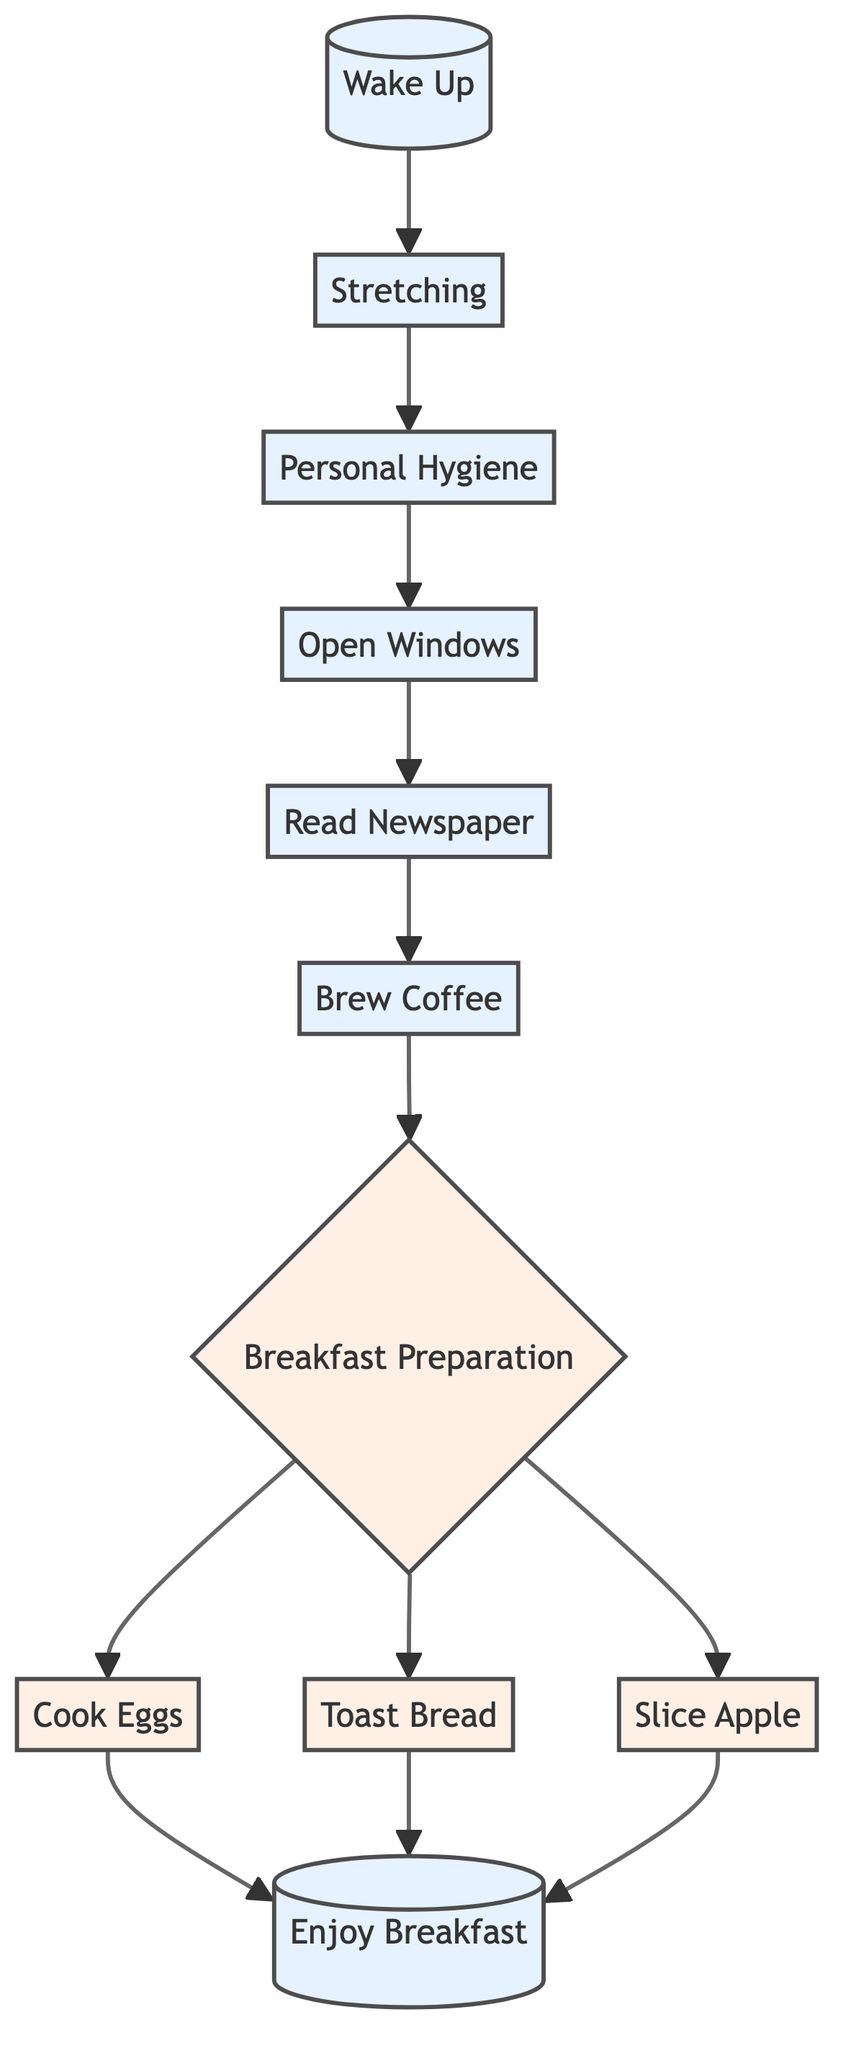What is the first step in the morning routine? The first step listed in the diagram is "Wake Up".
Answer: Wake Up How many tasks are involved in breakfast preparation? The breakfast preparation section has three tasks listed: Cook Eggs, Toast Bread, and Slice Apple. Therefore, the total number of tasks is three.
Answer: 3 What activity comes right after personal hygiene? The diagram shows that after "Personal Hygiene", the next step is "Open Windows".
Answer: Open Windows Which step involves reading the Smith Bend Tribune? The "Read Newspaper" step is where reading the Smith Bend Tribune occurs, as specified in the diagram.
Answer: Read Newspaper What step involves brewing coffee? The step that involves brewing coffee is labeled "Brew Coffee".
Answer: Brew Coffee What activities are connected to breakfast enjoyment? The "Enjoy Breakfast" step is connected to three preceding activities: Cooking Eggs, Toasting Bread, and Slicing Apple. These activities all lead up to enjoying breakfast.
Answer: Cook Eggs, Toast Bread, Slice Apple Which two steps are connected to the task of toasting bread? "Breakfast Preparation" is the step that connects to "Toast Bread" as one of its tasks along with "Cook Eggs" and "Slice Apple".
Answer: Breakfast Preparation What is the last step in the morning routine? The last step in the morning routine according to the diagram is "Enjoy Breakfast".
Answer: Enjoy Breakfast Which step follows opening windows and leads to breakfast preparation? The step that follows "Open Windows" and leads to "Breakfast Preparation" is "Read Newspaper".
Answer: Read Newspaper 